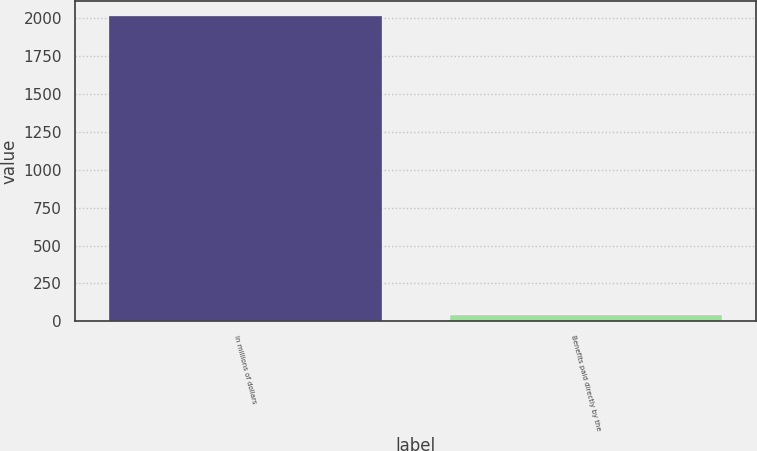<chart> <loc_0><loc_0><loc_500><loc_500><bar_chart><fcel>In millions of dollars<fcel>Benefits paid directly by the<nl><fcel>2016<fcel>44<nl></chart> 